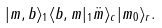Convert formula to latex. <formula><loc_0><loc_0><loc_500><loc_500>| m , b \rangle _ { 1 } \langle b , m | _ { 1 } \ddot { m } \rangle _ { c } | m _ { 0 } \rangle _ { r } .</formula> 